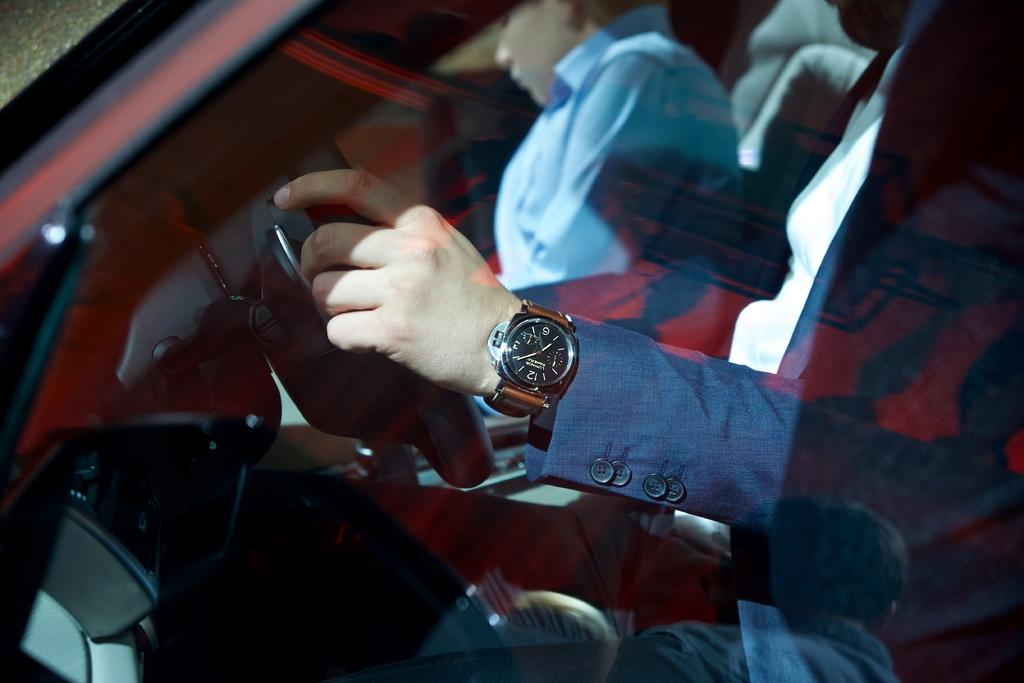What can be seen in the image related to a person's body part? There is a person's hand in the image. What is the person's hand holding or wearing? The person's hand is wearing a wrist watch. How many cows can be seen grazing in the background of the image? There are no cows present in the image; it only features a person's hand wearing a wrist watch. 